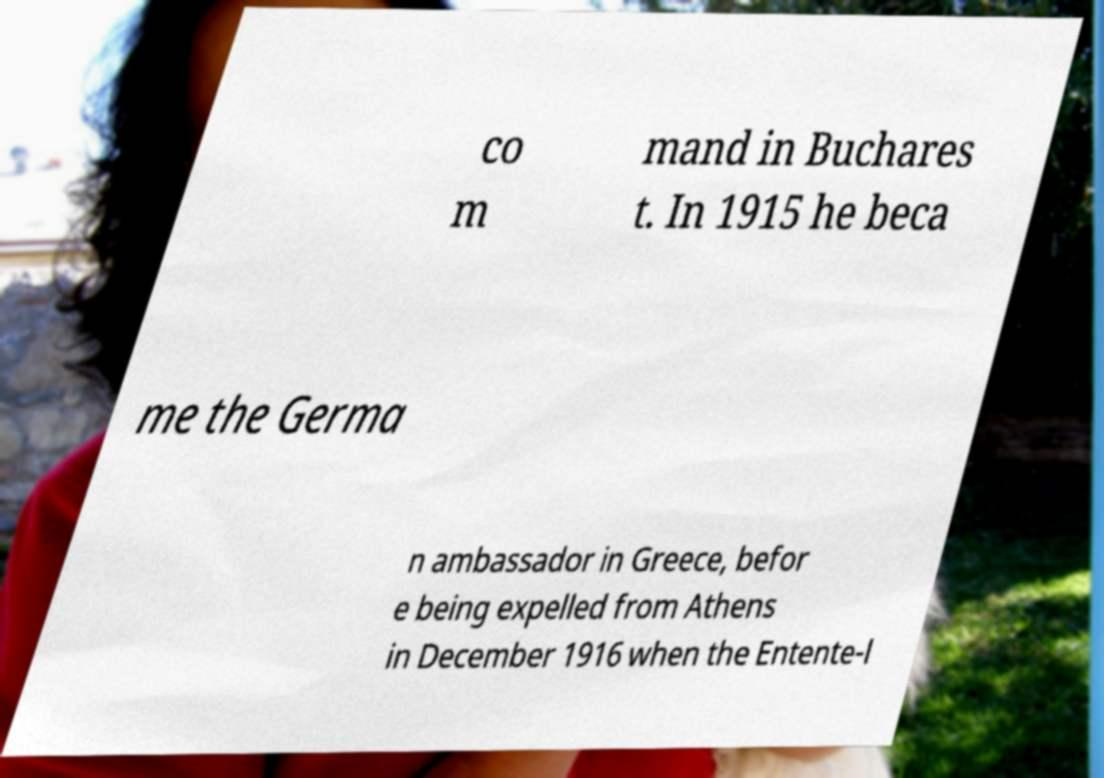For documentation purposes, I need the text within this image transcribed. Could you provide that? co m mand in Buchares t. In 1915 he beca me the Germa n ambassador in Greece, befor e being expelled from Athens in December 1916 when the Entente-l 